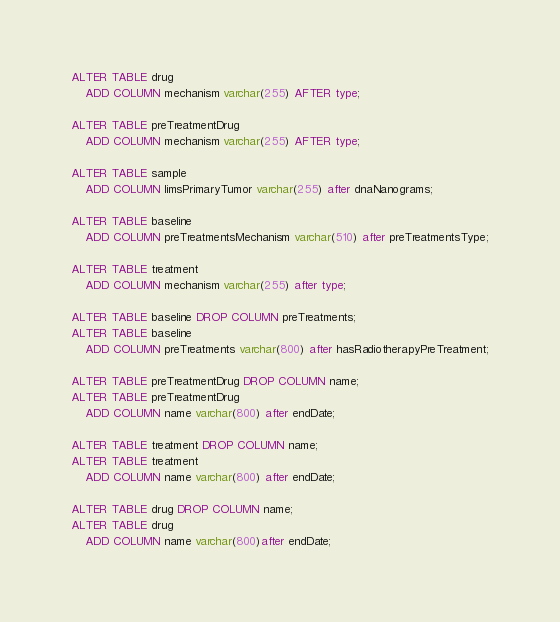Convert code to text. <code><loc_0><loc_0><loc_500><loc_500><_SQL_>ALTER TABLE drug
    ADD COLUMN mechanism varchar(255) AFTER type;

ALTER TABLE preTreatmentDrug
    ADD COLUMN mechanism varchar(255) AFTER type;

ALTER TABLE sample
    ADD COLUMN limsPrimaryTumor varchar(255) after dnaNanograms;

ALTER TABLE baseline
    ADD COLUMN preTreatmentsMechanism varchar(510) after preTreatmentsType;

ALTER TABLE treatment
    ADD COLUMN mechanism varchar(255) after type;

ALTER TABLE baseline DROP COLUMN preTreatments;
ALTER TABLE baseline
    ADD COLUMN preTreatments varchar(800) after hasRadiotherapyPreTreatment;

ALTER TABLE preTreatmentDrug DROP COLUMN name;
ALTER TABLE preTreatmentDrug
    ADD COLUMN name varchar(800) after endDate;

ALTER TABLE treatment DROP COLUMN name;
ALTER TABLE treatment
    ADD COLUMN name varchar(800) after endDate;

ALTER TABLE drug DROP COLUMN name;
ALTER TABLE drug
    ADD COLUMN name varchar(800)after endDate;</code> 